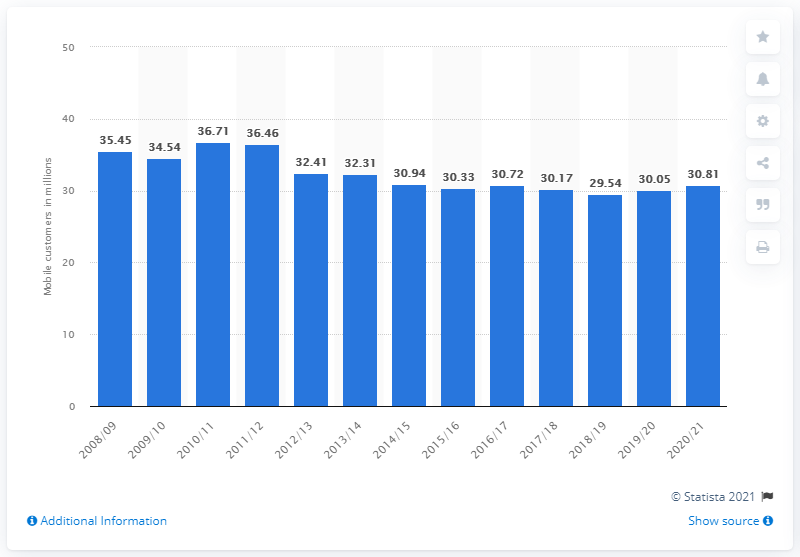Mention a couple of crucial points in this snapshot. Vodafone had approximately 30.05 million mobile customers in Germany in the previous year. As of the end of the corporate year 2020/21, Vodafone had a total of 30.81 mobile customers. 